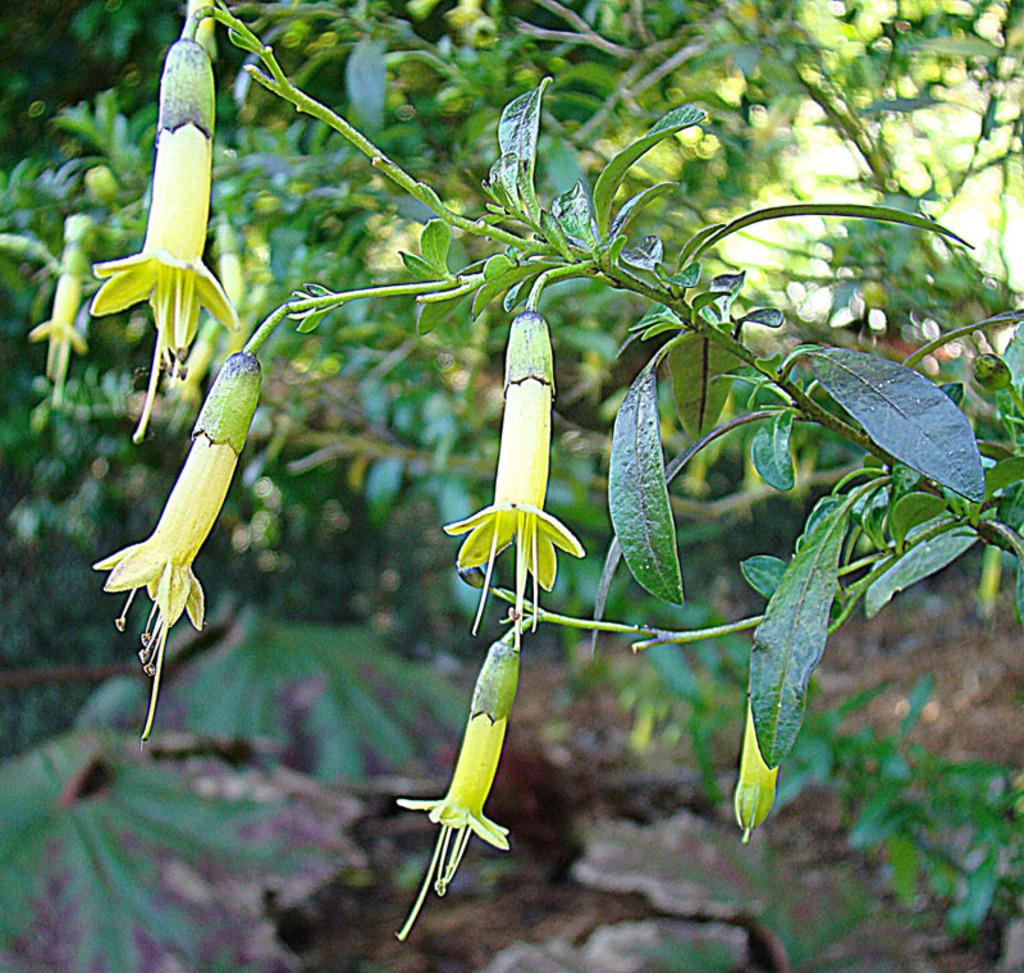What types of living organisms can be seen in the image? There are many plants in the image. What specific features can be observed on the plants? There are flowers on the plants in the image. How many rings can be seen on the toe of the person in the image? There is no person present in the image, and therefore no toes or rings can be observed. 